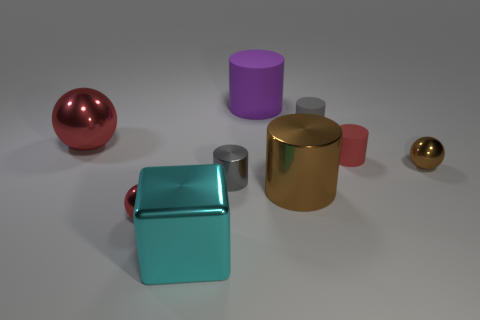There is a red ball that is the same size as the purple cylinder; what is it made of?
Ensure brevity in your answer.  Metal. The small cylinder that is both right of the big matte object and in front of the large metal ball is made of what material?
Your response must be concise. Rubber. There is a big cylinder that is behind the large red metallic object; is there a shiny sphere on the right side of it?
Your answer should be very brief. Yes. What size is the object that is behind the big metal block and in front of the large brown cylinder?
Your answer should be compact. Small. How many brown things are large cubes or large cylinders?
Offer a very short reply. 1. The gray metal thing that is the same size as the gray matte object is what shape?
Keep it short and to the point. Cylinder. How many other things are the same color as the big metal ball?
Provide a short and direct response. 2. There is a block right of the small red object in front of the red matte cylinder; what size is it?
Make the answer very short. Large. Do the small sphere that is right of the cyan cube and the large red object have the same material?
Your response must be concise. Yes. There is a small shiny thing to the right of the tiny red matte thing; what is its shape?
Offer a terse response. Sphere. 